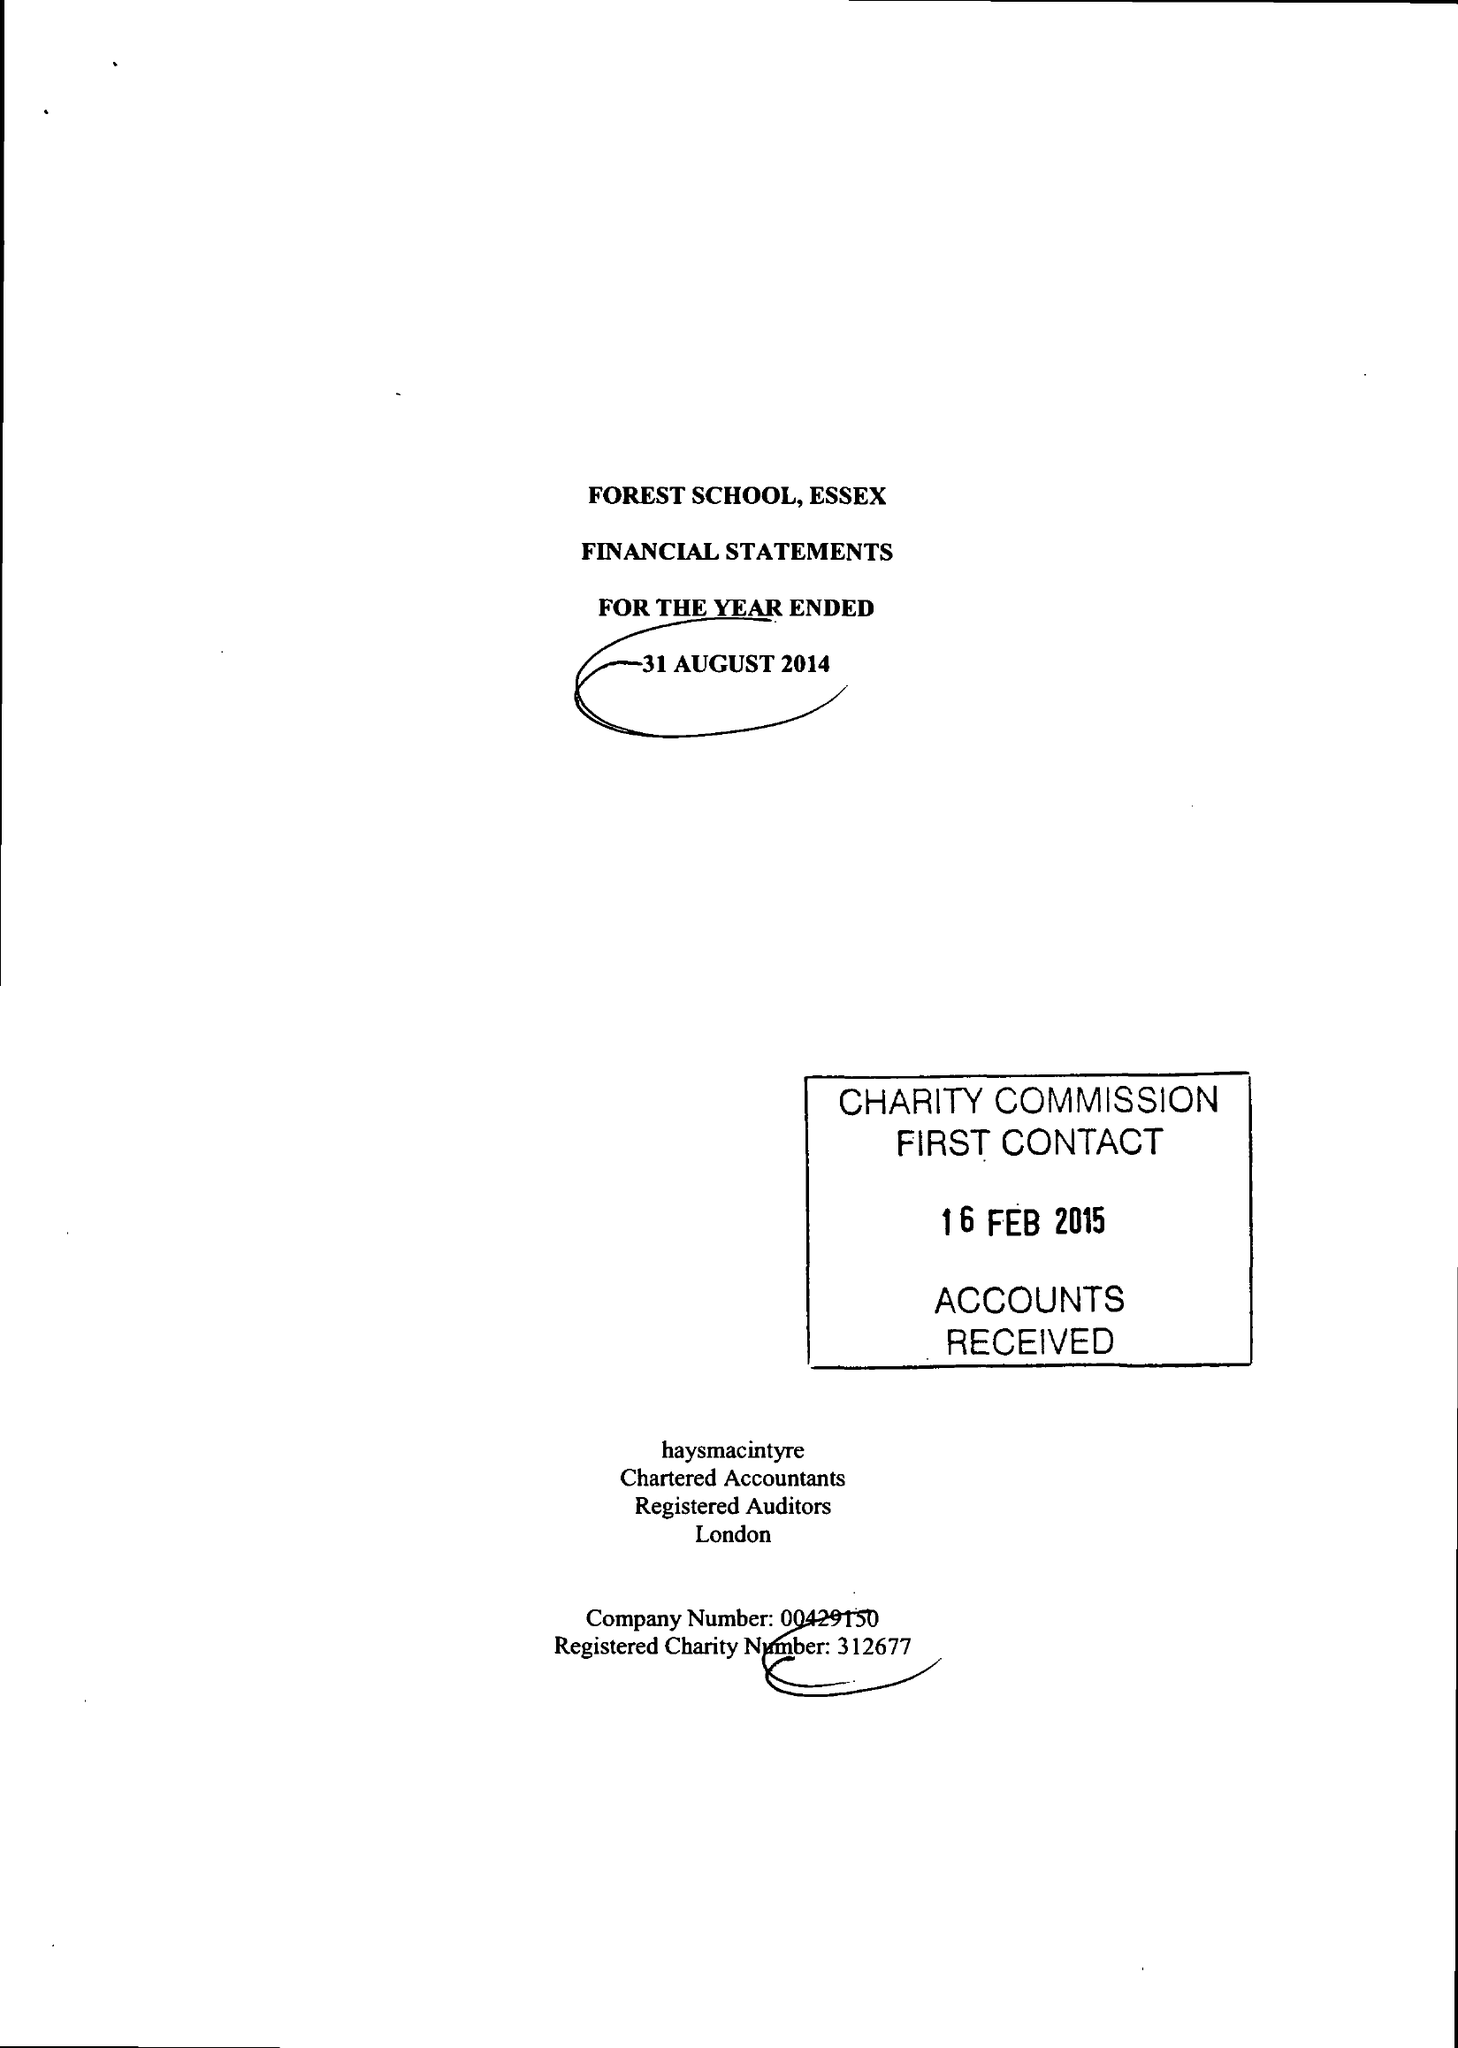What is the value for the charity_number?
Answer the question using a single word or phrase. 312677 